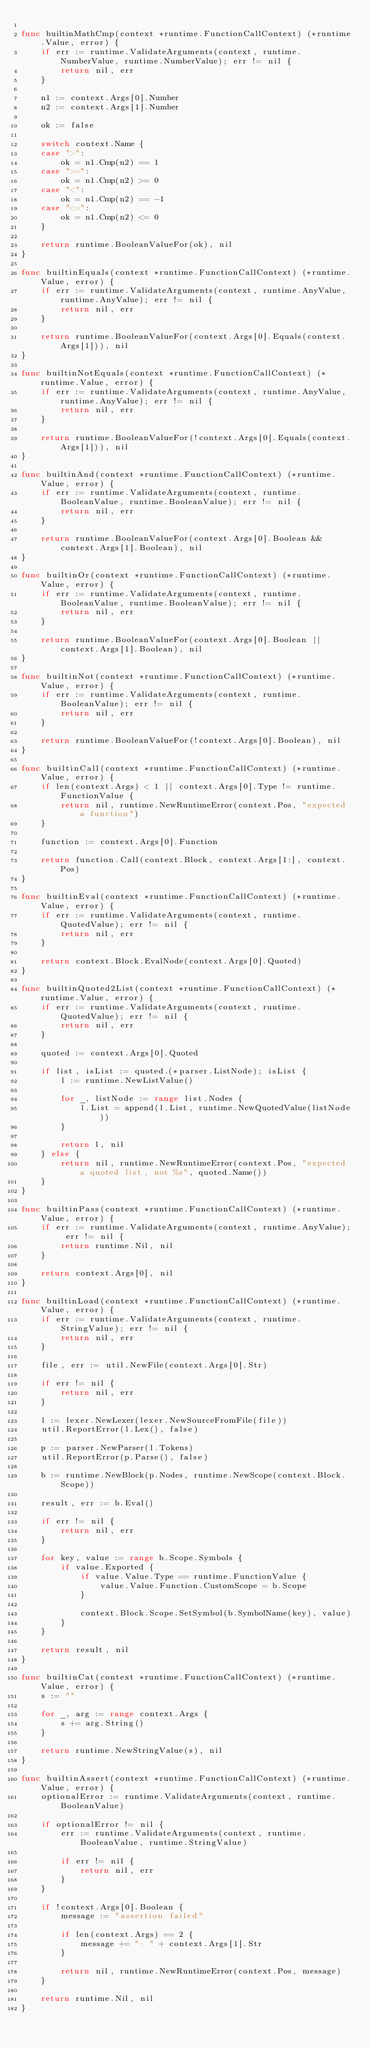<code> <loc_0><loc_0><loc_500><loc_500><_Go_>
func builtinMathCmp(context *runtime.FunctionCallContext) (*runtime.Value, error) {
	if err := runtime.ValidateArguments(context, runtime.NumberValue, runtime.NumberValue); err != nil {
		return nil, err
	}

	n1 := context.Args[0].Number
	n2 := context.Args[1].Number

	ok := false

	switch context.Name {
	case ">":
		ok = n1.Cmp(n2) == 1
	case ">=":
		ok = n1.Cmp(n2) >= 0
	case "<":
		ok = n1.Cmp(n2) == -1
	case "<=":
		ok = n1.Cmp(n2) <= 0
	}

	return runtime.BooleanValueFor(ok), nil
}

func builtinEquals(context *runtime.FunctionCallContext) (*runtime.Value, error) {
	if err := runtime.ValidateArguments(context, runtime.AnyValue, runtime.AnyValue); err != nil {
		return nil, err
	}

	return runtime.BooleanValueFor(context.Args[0].Equals(context.Args[1])), nil
}

func builtinNotEquals(context *runtime.FunctionCallContext) (*runtime.Value, error) {
	if err := runtime.ValidateArguments(context, runtime.AnyValue, runtime.AnyValue); err != nil {
		return nil, err
	}

	return runtime.BooleanValueFor(!context.Args[0].Equals(context.Args[1])), nil
}

func builtinAnd(context *runtime.FunctionCallContext) (*runtime.Value, error) {
	if err := runtime.ValidateArguments(context, runtime.BooleanValue, runtime.BooleanValue); err != nil {
		return nil, err
	}

	return runtime.BooleanValueFor(context.Args[0].Boolean && context.Args[1].Boolean), nil
}

func builtinOr(context *runtime.FunctionCallContext) (*runtime.Value, error) {
	if err := runtime.ValidateArguments(context, runtime.BooleanValue, runtime.BooleanValue); err != nil {
		return nil, err
	}

	return runtime.BooleanValueFor(context.Args[0].Boolean || context.Args[1].Boolean), nil
}

func builtinNot(context *runtime.FunctionCallContext) (*runtime.Value, error) {
	if err := runtime.ValidateArguments(context, runtime.BooleanValue); err != nil {
		return nil, err
	}

	return runtime.BooleanValueFor(!context.Args[0].Boolean), nil
}

func builtinCall(context *runtime.FunctionCallContext) (*runtime.Value, error) {
	if len(context.Args) < 1 || context.Args[0].Type != runtime.FunctionValue {
		return nil, runtime.NewRuntimeError(context.Pos, "expected a function")
	}

	function := context.Args[0].Function

	return function.Call(context.Block, context.Args[1:], context.Pos)
}

func builtinEval(context *runtime.FunctionCallContext) (*runtime.Value, error) {
	if err := runtime.ValidateArguments(context, runtime.QuotedValue); err != nil {
		return nil, err
	}

	return context.Block.EvalNode(context.Args[0].Quoted)
}

func builtinQuoted2List(context *runtime.FunctionCallContext) (*runtime.Value, error) {
	if err := runtime.ValidateArguments(context, runtime.QuotedValue); err != nil {
		return nil, err
	}

	quoted := context.Args[0].Quoted

	if list, isList := quoted.(*parser.ListNode); isList {
		l := runtime.NewListValue()

		for _, listNode := range list.Nodes {
			l.List = append(l.List, runtime.NewQuotedValue(listNode))
		}

		return l, nil
	} else {
		return nil, runtime.NewRuntimeError(context.Pos, "expected a quoted list, not %s", quoted.Name())
	}
}

func builtinPass(context *runtime.FunctionCallContext) (*runtime.Value, error) {
	if err := runtime.ValidateArguments(context, runtime.AnyValue); err != nil {
		return runtime.Nil, nil
	}

	return context.Args[0], nil
}

func builtinLoad(context *runtime.FunctionCallContext) (*runtime.Value, error) {
	if err := runtime.ValidateArguments(context, runtime.StringValue); err != nil {
		return nil, err
	}

	file, err := util.NewFile(context.Args[0].Str)

	if err != nil {
		return nil, err
	}

	l := lexer.NewLexer(lexer.NewSourceFromFile(file))
	util.ReportError(l.Lex(), false)

	p := parser.NewParser(l.Tokens)
	util.ReportError(p.Parse(), false)

	b := runtime.NewBlock(p.Nodes, runtime.NewScope(context.Block.Scope))

	result, err := b.Eval()

	if err != nil {
		return nil, err
	}

	for key, value := range b.Scope.Symbols {
		if value.Exported {
			if value.Value.Type == runtime.FunctionValue {
				value.Value.Function.CustomScope = b.Scope
			}

			context.Block.Scope.SetSymbol(b.SymbolName(key), value)
		}
	}

	return result, nil
}

func builtinCat(context *runtime.FunctionCallContext) (*runtime.Value, error) {
	s := ""

	for _, arg := range context.Args {
		s += arg.String()
	}

	return runtime.NewStringValue(s), nil
}

func builtinAssert(context *runtime.FunctionCallContext) (*runtime.Value, error) {
	optionalError := runtime.ValidateArguments(context, runtime.BooleanValue)

	if optionalError != nil {
		err := runtime.ValidateArguments(context, runtime.BooleanValue, runtime.StringValue)

		if err != nil {
			return nil, err
		}
	}

	if !context.Args[0].Boolean {
		message := "assertion failed"

		if len(context.Args) == 2 {
			message += ": " + context.Args[1].Str
		}

		return nil, runtime.NewRuntimeError(context.Pos, message)
	}

	return runtime.Nil, nil
}
</code> 